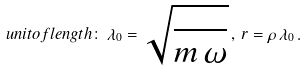Convert formula to latex. <formula><loc_0><loc_0><loc_500><loc_500>u n i t o f l e n g t h \colon \, \lambda _ { 0 } = \sqrt { \frac { } { m \, \omega } } \, , \, r = \rho \, \lambda _ { 0 } \, .</formula> 